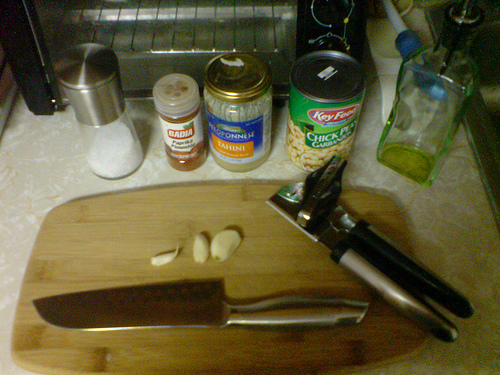<image>
Is the table under the knife? Yes. The table is positioned underneath the knife, with the knife above it in the vertical space. 